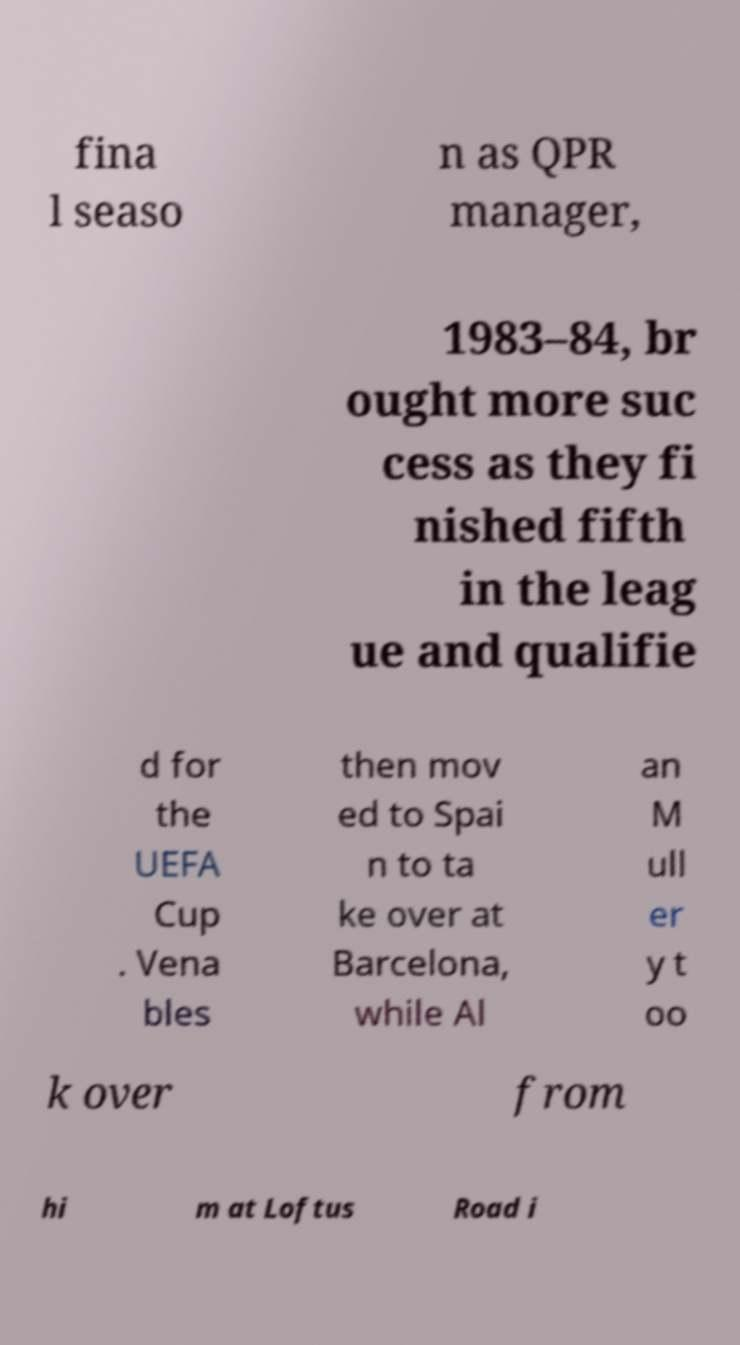Could you assist in decoding the text presented in this image and type it out clearly? fina l seaso n as QPR manager, 1983–84, br ought more suc cess as they fi nished fifth in the leag ue and qualifie d for the UEFA Cup . Vena bles then mov ed to Spai n to ta ke over at Barcelona, while Al an M ull er y t oo k over from hi m at Loftus Road i 